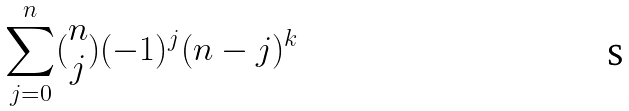<formula> <loc_0><loc_0><loc_500><loc_500>\sum _ { j = 0 } ^ { n } ( \begin{matrix} n \\ j \end{matrix} ) ( - 1 ) ^ { j } ( n - j ) ^ { k }</formula> 